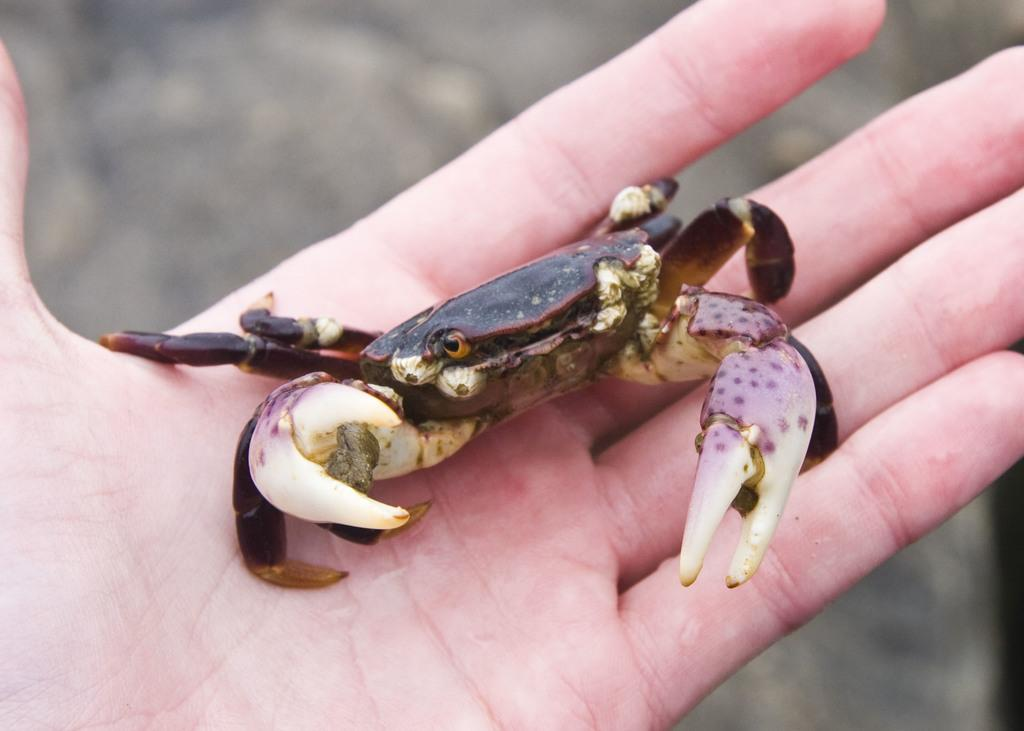What is the main subject in the foreground of the image? There is a person in the foreground of the image. What is the person holding in the image? The person is holding a crab. Can you describe the background of the image? The background of the image is blurred. How many geese are visible in the image? There are no geese present in the image. What type of lace is being used to decorate the crab in the image? There is no lace present in the image, and the crab is not being decorated. 